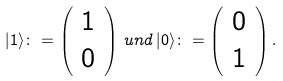<formula> <loc_0><loc_0><loc_500><loc_500>| 1 \rangle \colon = \left ( \begin{array} { * { 1 } { c } } 1 \\ 0 \end{array} \right ) \, u n d \, | 0 \rangle \colon = \left ( \begin{array} { * { 1 } { c } } 0 \\ 1 \end{array} \right ) .</formula> 